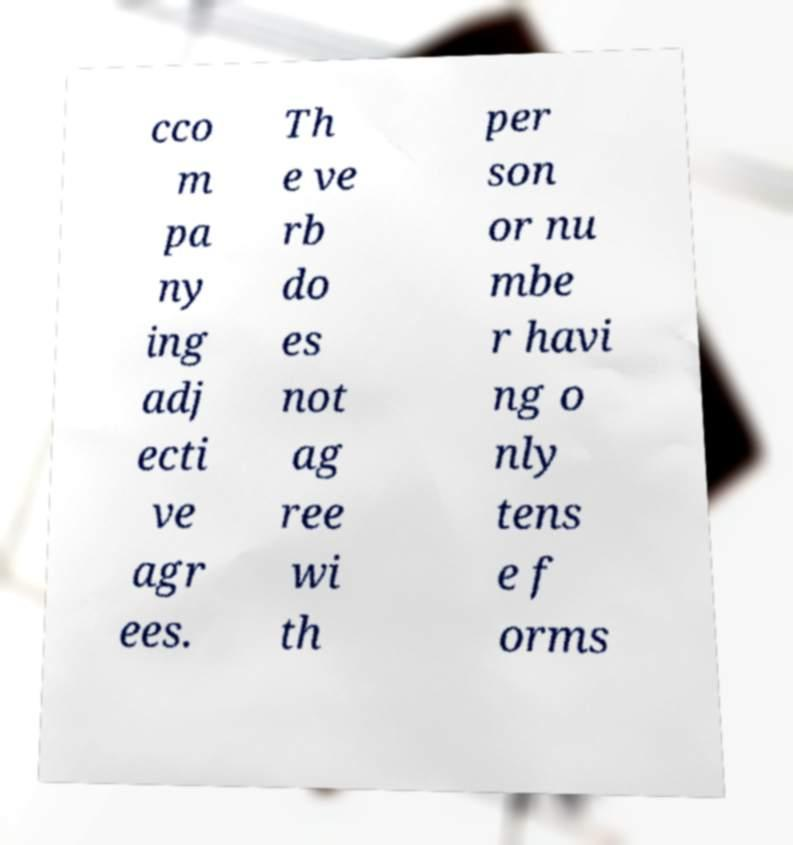For documentation purposes, I need the text within this image transcribed. Could you provide that? cco m pa ny ing adj ecti ve agr ees. Th e ve rb do es not ag ree wi th per son or nu mbe r havi ng o nly tens e f orms 